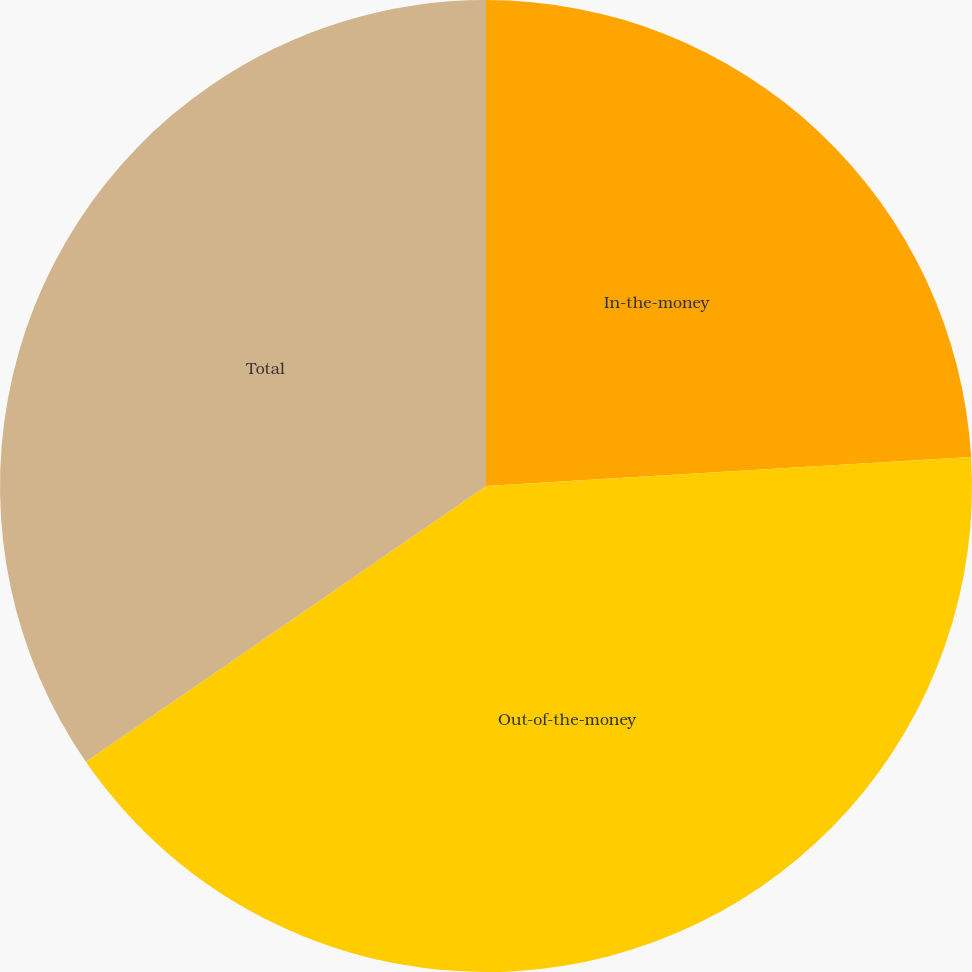Convert chart to OTSL. <chart><loc_0><loc_0><loc_500><loc_500><pie_chart><fcel>In-the-money<fcel>Out-of-the-money<fcel>Total<nl><fcel>24.05%<fcel>41.35%<fcel>34.61%<nl></chart> 